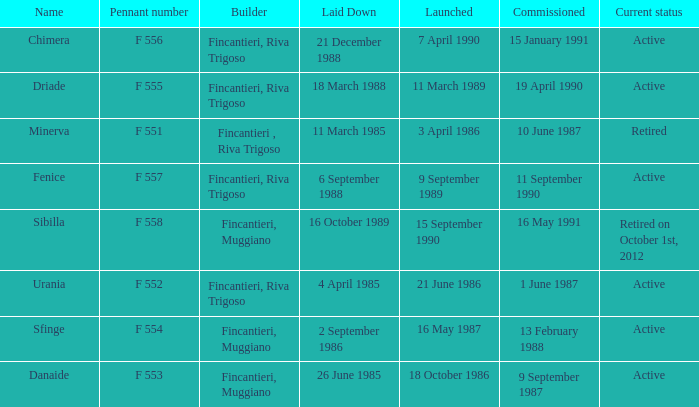What builder is now retired F 551. 